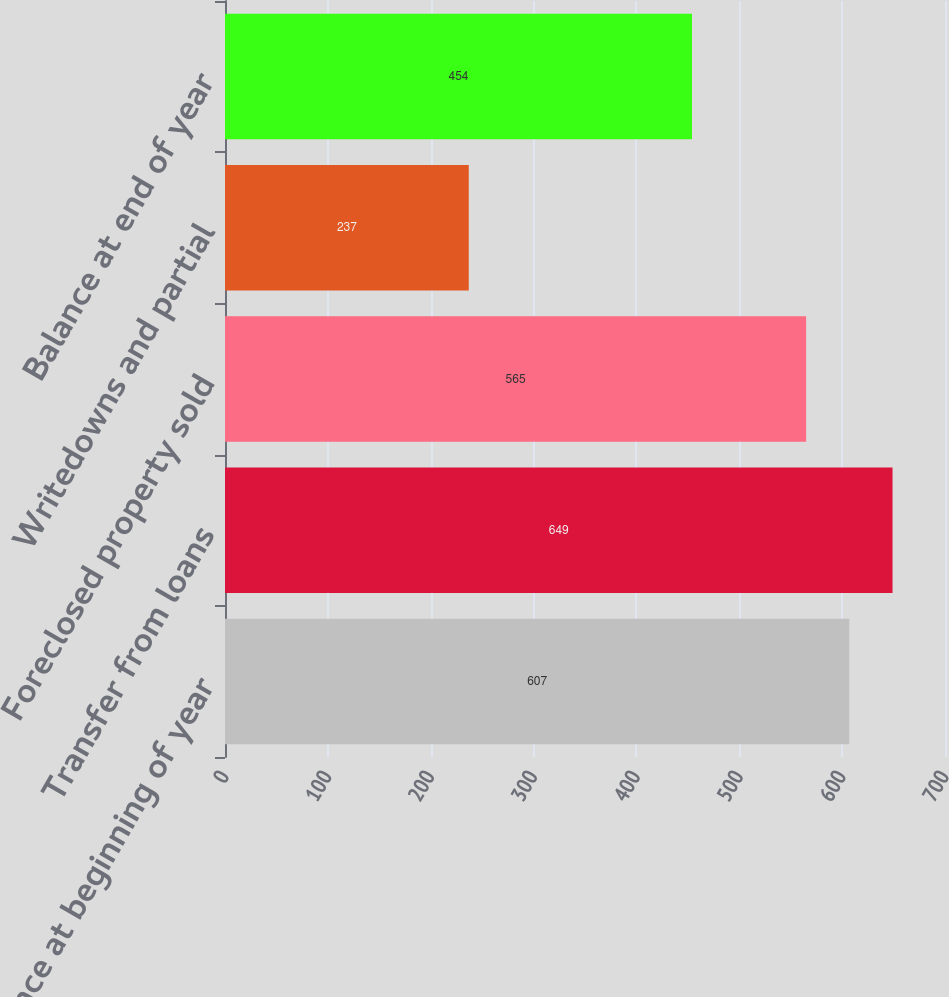Convert chart. <chart><loc_0><loc_0><loc_500><loc_500><bar_chart><fcel>Balance at beginning of year<fcel>Transfer from loans<fcel>Foreclosed property sold<fcel>Writedowns and partial<fcel>Balance at end of year<nl><fcel>607<fcel>649<fcel>565<fcel>237<fcel>454<nl></chart> 